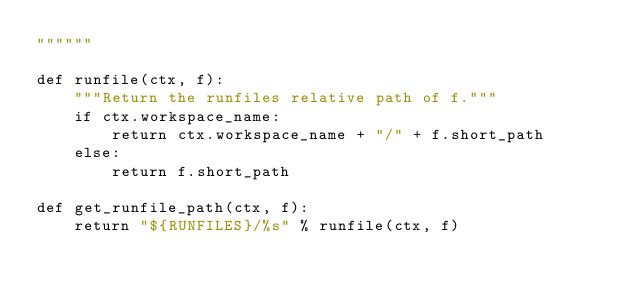Convert code to text. <code><loc_0><loc_0><loc_500><loc_500><_Python_>""""""

def runfile(ctx, f):
    """Return the runfiles relative path of f."""
    if ctx.workspace_name:
        return ctx.workspace_name + "/" + f.short_path
    else:
        return f.short_path

def get_runfile_path(ctx, f):
    return "${RUNFILES}/%s" % runfile(ctx, f)
</code> 